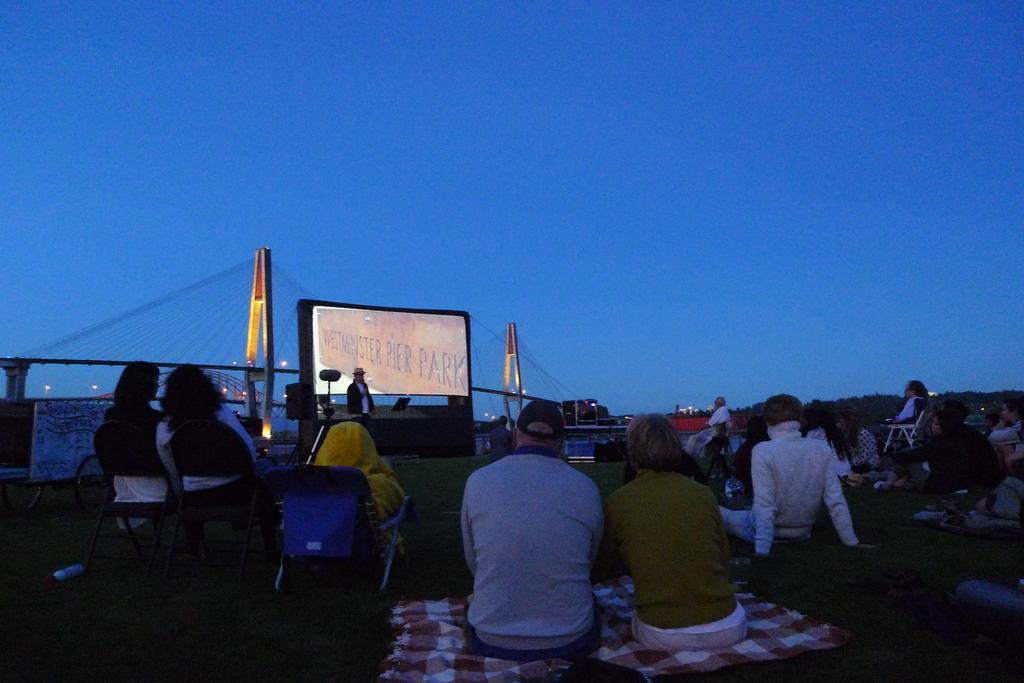How would you summarize this image in a sentence or two? In this image we can see some people sitting on the ground and some are sitting on a chair. In the background, we can see a person standing and in front of him there is a stand with a book and there is a screen. We can also see a bridge and the sky. 